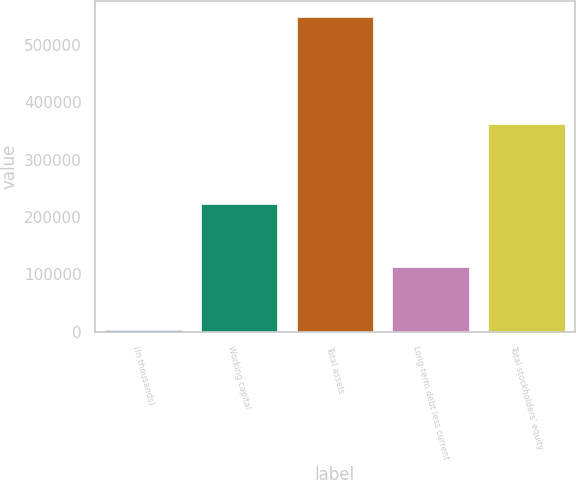Convert chart. <chart><loc_0><loc_0><loc_500><loc_500><bar_chart><fcel>(In thousands)<fcel>Working capital<fcel>Total assets<fcel>Long-term debt less current<fcel>Total stockholders' equity<nl><fcel>2004<fcel>222230<fcel>549151<fcel>113250<fcel>361499<nl></chart> 